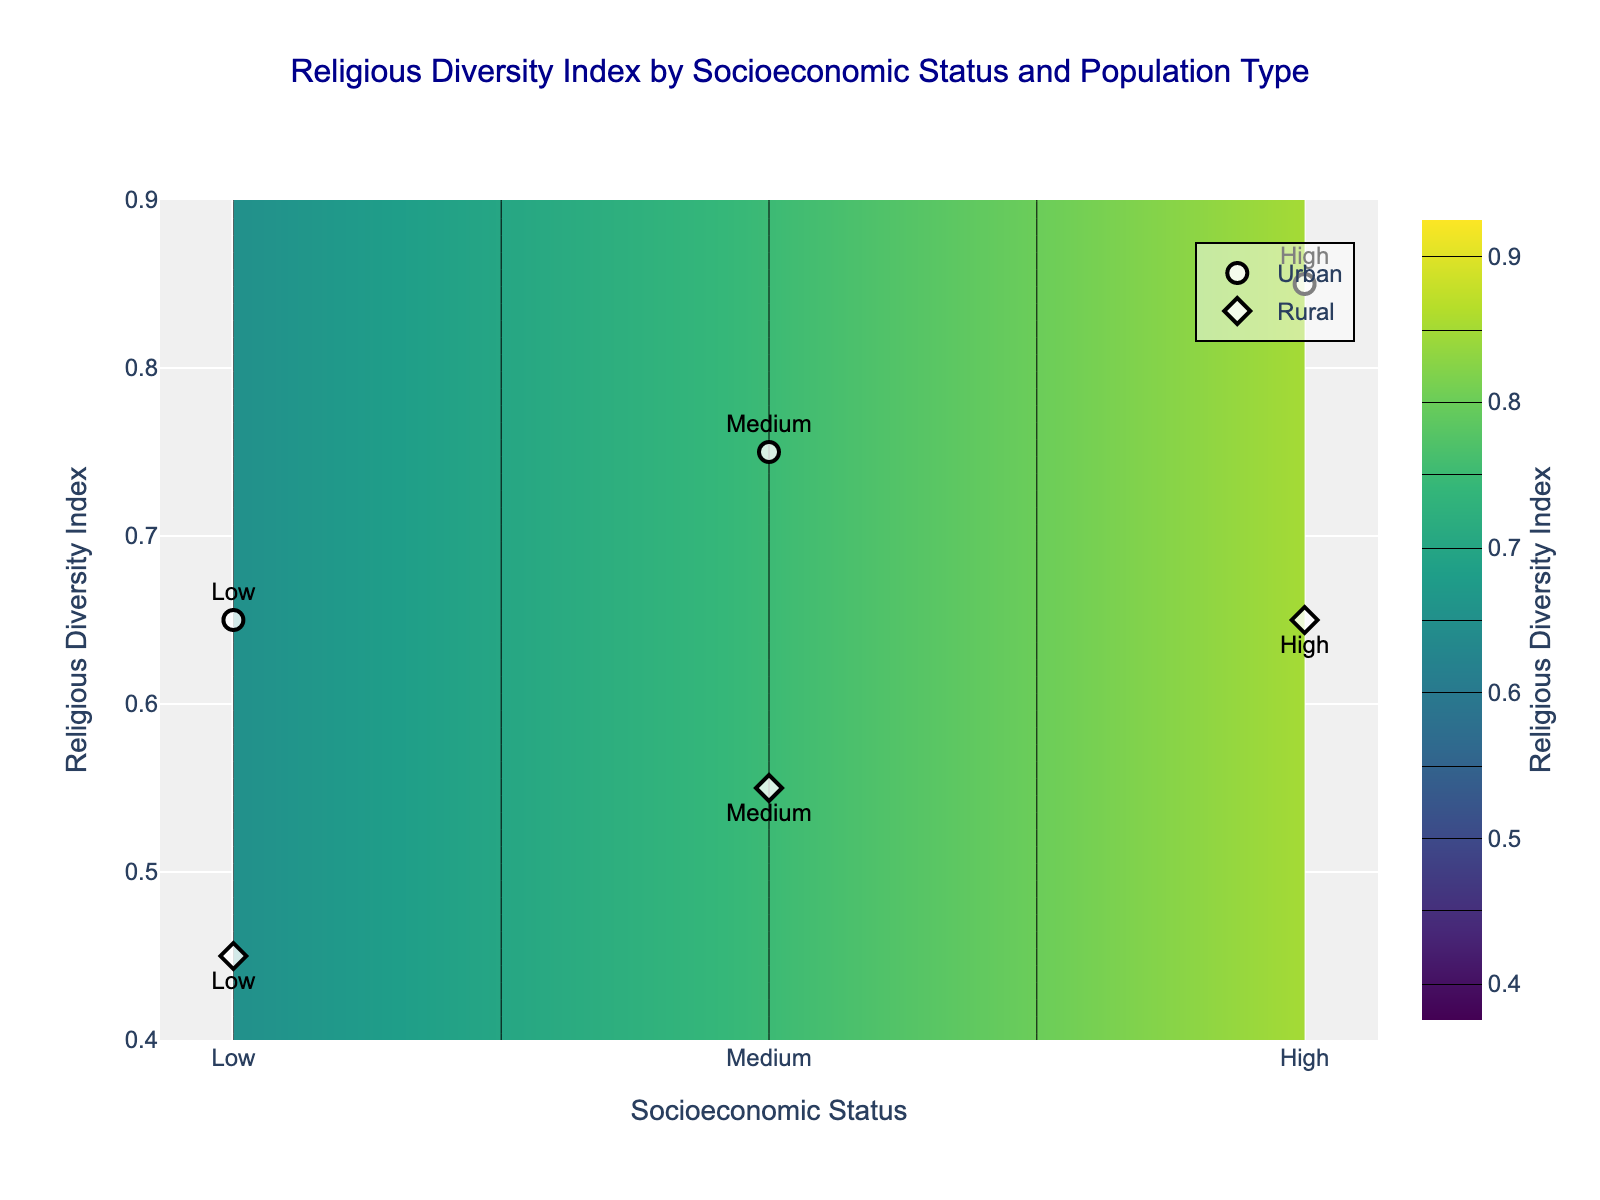What is the title of the figure? The title of the figure is usually presented at the top center of the plot. In this case, it reads "Religious Diversity Index by Socioeconomic Status and Population Type."
Answer: Religious Diversity Index by Socioeconomic Status and Population Type What is the highest Religious Diversity Index observed for rural populations? To find the highest Religious Diversity Index for rural populations, locate the points associated with rural populations, which use diamond markers. The highest value among the rural points is 0.65 for high socioeconomic status.
Answer: 0.65 How does the Religious Diversity Index change from low to high socioeconomic status in urban populations? Observe the scatter plot markers for urban populations (circle markers). For low, medium, and high socioeconomic statuses, the Religious Diversity Index changes from 0.65 to 0.75 to 0.85 respectively, indicating an increasing trend.
Answer: It increases Which population type shows a wider range in the Religious Diversity Index? Compare the range of the Religious Diversity Index in both urban (0.65 to 0.85) and rural (0.45 to 0.65) population types. The range for urban populations spans 0.20 (0.85 - 0.65), while for rural populations it spans 0.20 (0.65 - 0.45). Both ranges are equal.
Answer: Both are equal Compare the Religious Diversity Index for medium socioeconomic status between urban and rural populations. For medium socioeconomic status, look at the points labeled "Medium." The Religious Diversity Index is 0.75 for urban populations (circle marker) and 0.55 for rural populations (diamond marker). Thus, the urban index is higher.
Answer: Urban is higher What visual elements indicate the variation in the Religious Diversity Index for the different socioeconomic statuses? The contour plot uses a color gradient (Viridis colorscale) to represent different levels of the Religious Diversity Index. Darker colors signify lower values, while lighter colors represent higher values. Additionally, labeled markers for low, medium, and high socioeconomic statuses show specific data points.
Answer: Color gradient and labeled markers Is there a socioeconomic status that has the same Religious Diversity Index in both urban and rural populations? Check each socioeconomic status (Low, Medium, High) for both population types. There is no socioeconomic status where urban and rural populations have the same Religious Diversity Index values.
Answer: No What is the general trend observed in the Religious Diversity Index as socioeconomic status increases within urban populations? By observing the plot, the trend within urban populations shows an increase in the Religious Diversity Index as socioeconomic status moves from low to high. This is visually evident as the contour bands and data points (circles) shift upwards.
Answer: Increasing How does the contour plot indicate regions of high and low Religious Diversity Index? The contour plot utilizes a heatmap color gradient, with lighter regions indicating higher Religious Diversity Index values and darker regions indicating lower values. The contour lines also help demarcate these regions more clearly.
Answer: Lighter regions are higher, darker regions are lower 